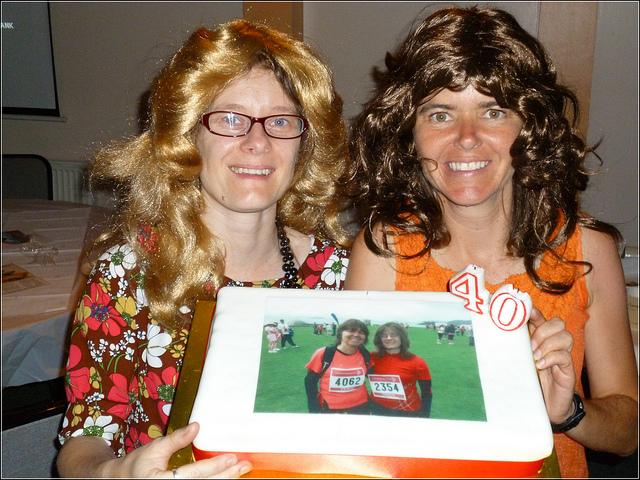Do identical twins have 100% the same DNA? Please explain your reasoning. true. Yes, because they are one fertilized egg which has split onto 2. 